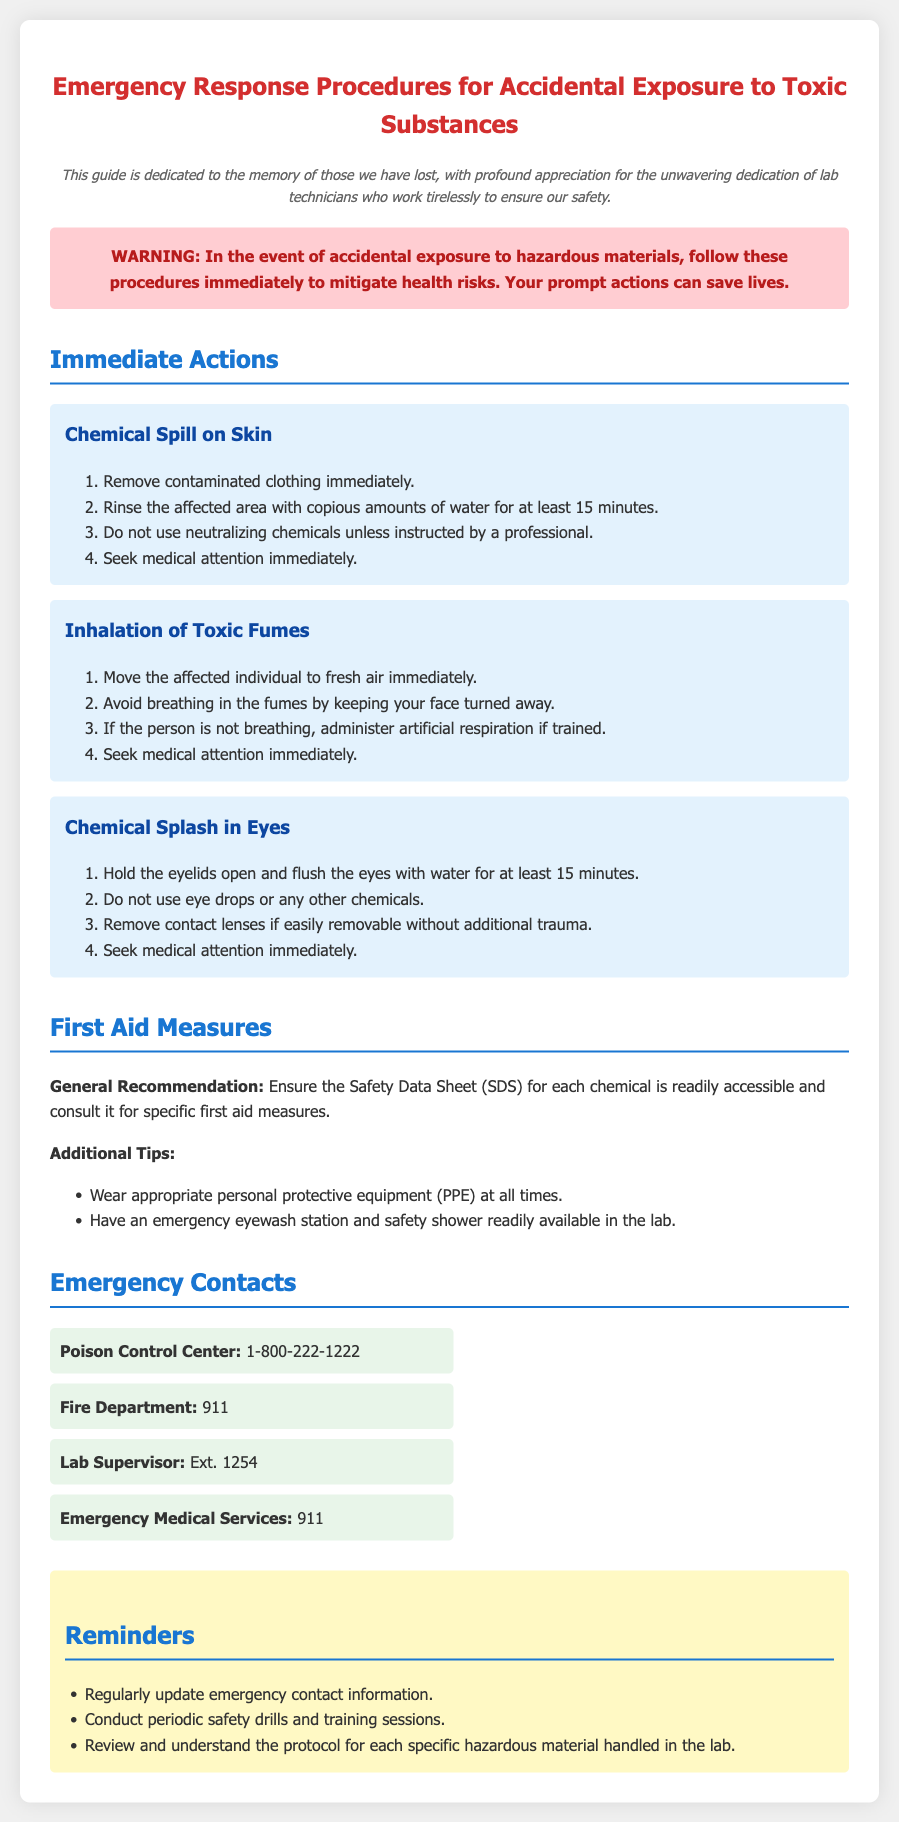What is the title of the document? The title is prominently displayed at the top of the document, serving as the main heading.
Answer: Emergency Response Procedures for Accidental Exposure to Toxic Substances What is the primary focus of the warning section? The warning section emphasizes immediate actions to mitigate health risks following exposure to hazardous materials.
Answer: Follow these procedures immediately to mitigate health risks How long should you rinse a chemical spill on the skin? The document specifies a duration for rinsing the affected area with water in case of a chemical spill.
Answer: 15 minutes What should you do if someone inhales toxic fumes? The procedures for inhalation provide clear steps on what to do immediately after such an incident occurs.
Answer: Move the affected individual to fresh air immediately Which organization is listed for Poison Control? The document provides a specific contact number for a poison control resource.
Answer: 1-800-222-1222 What should you do after a chemical splash in the eyes? The document outlines steps to take specifically for eye exposure to chemicals.
Answer: Hold the eyelids open and flush the eyes with water for at least 15 minutes What is a general recommendation provided in the First Aid Measures section? The document mentions a specific document that should be readily accessible for each chemical.
Answer: Ensure the Safety Data Sheet (SDS) for each chemical is readily accessible Which emergency service number should be called for medical assistance? The document lists emergency numbers for various services, including medical help.
Answer: 911 